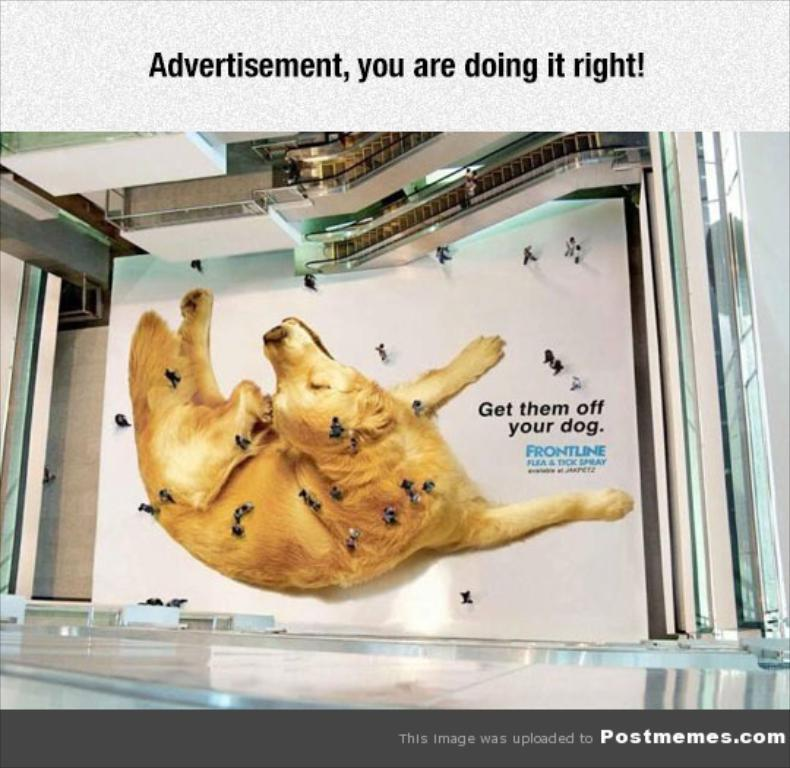What is depicted on the floor in the image? There is a picture of a dog on the floor. Who or what else can be seen in the image? There are people in the image. What can be seen in the background of the image? There are escalators and some objects in the background of the image. Is there any text visible in the image? Yes, there is text visible in the image. What language is the goat speaking in the image? There is no goat present in the image, and therefore no language spoken by a goat can be observed. What story is being told by the people in the image? The image does not depict a specific story being told by the people; it only shows their presence in the scene. 